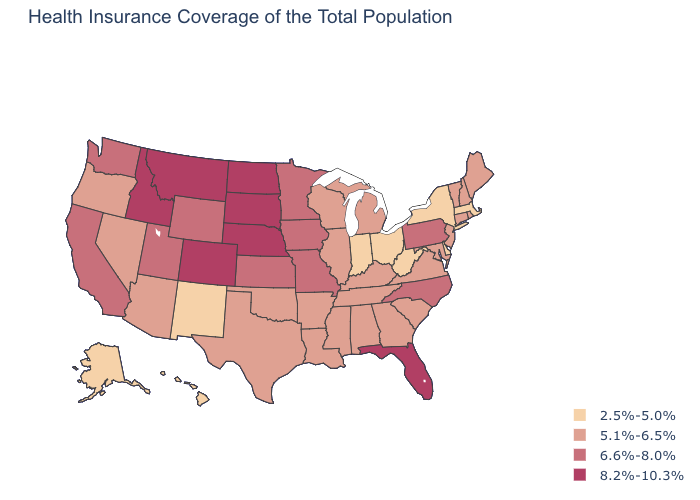How many symbols are there in the legend?
Concise answer only. 4. Does Colorado have the highest value in the USA?
Write a very short answer. Yes. What is the lowest value in the USA?
Short answer required. 2.5%-5.0%. Name the states that have a value in the range 6.6%-8.0%?
Keep it brief. California, Iowa, Kansas, Minnesota, Missouri, North Carolina, Pennsylvania, Utah, Washington, Wyoming. Does Wisconsin have the highest value in the MidWest?
Concise answer only. No. What is the lowest value in the USA?
Concise answer only. 2.5%-5.0%. What is the highest value in the USA?
Quick response, please. 8.2%-10.3%. What is the lowest value in the USA?
Give a very brief answer. 2.5%-5.0%. What is the highest value in the South ?
Keep it brief. 8.2%-10.3%. Which states have the lowest value in the MidWest?
Give a very brief answer. Indiana, Ohio. What is the lowest value in the West?
Be succinct. 2.5%-5.0%. How many symbols are there in the legend?
Short answer required. 4. Which states have the highest value in the USA?
Give a very brief answer. Colorado, Florida, Idaho, Montana, Nebraska, North Dakota, South Dakota. What is the highest value in the South ?
Answer briefly. 8.2%-10.3%. Name the states that have a value in the range 5.1%-6.5%?
Write a very short answer. Alabama, Arizona, Arkansas, Connecticut, Georgia, Illinois, Kentucky, Louisiana, Maine, Maryland, Michigan, Mississippi, Nevada, New Hampshire, New Jersey, Oklahoma, Oregon, Rhode Island, South Carolina, Tennessee, Texas, Vermont, Virginia, Wisconsin. 